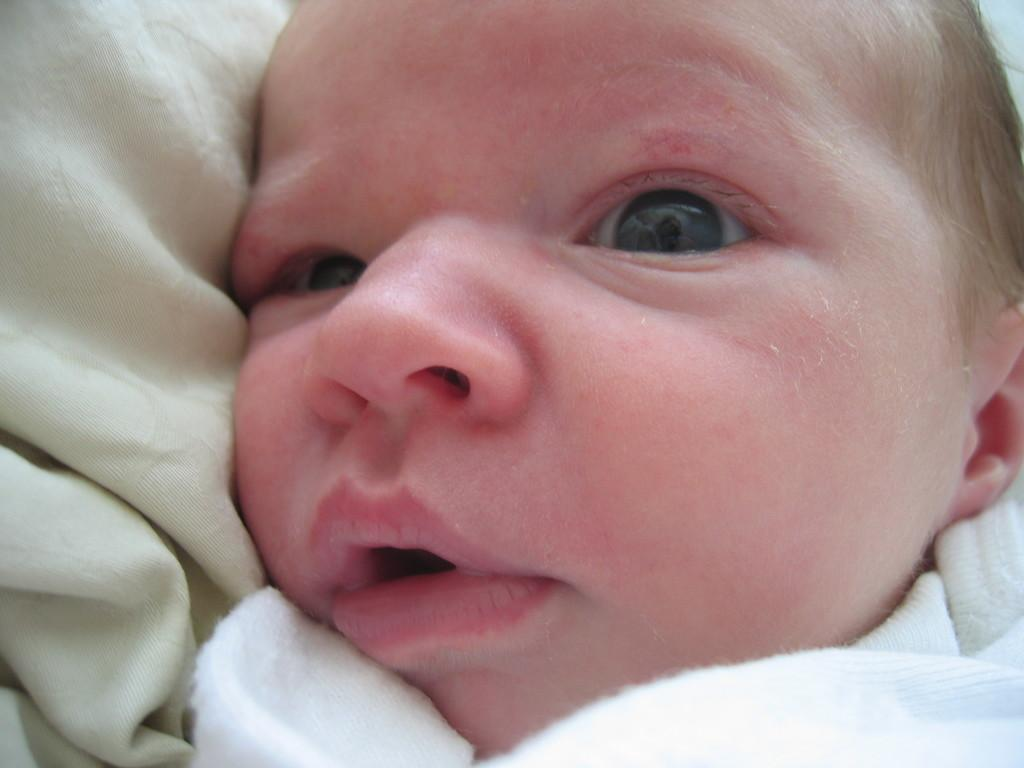What is the main subject of the image? The main subject of the image is a kid. What else can be seen in the image besides the kid? There are clothes in the image. What type of owl can be seen in the image? There is no owl present in the image; it only features a kid and clothes. 